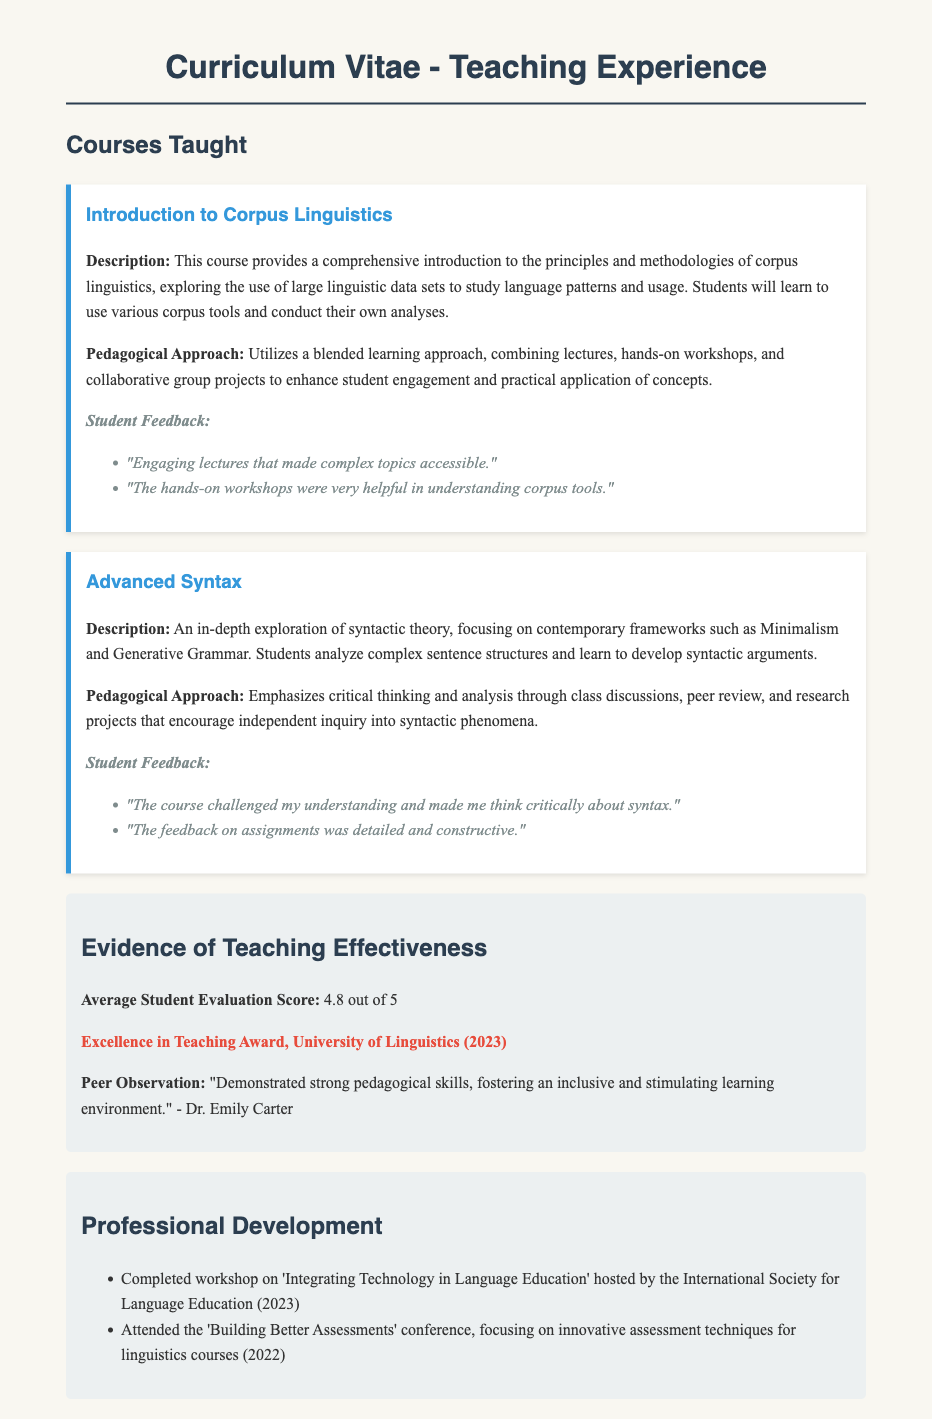What is the title of the first course taught? The title of the first course is found at the beginning of the course section, which is "Introduction to Corpus Linguistics."
Answer: Introduction to Corpus Linguistics What is the average student evaluation score? The average student evaluation score is explicitly stated in the section on evidence of teaching effectiveness, which is 4.8 out of 5.
Answer: 4.8 out of 5 What award did the instructor receive in 2023? The award is mentioned in the effectiveness section, where it states "Excellence in Teaching Award, University of Linguistics (2023)."
Answer: Excellence in Teaching Award What pedagogical approach is used in Advanced Syntax? The pedagogical approach for Advanced Syntax is described, focusing on critical thinking and analysis through class discussions, which outlines how the course is taught.
Answer: Emphasizes critical thinking and analysis Who provided the peer observation comment? The peer observation comment is attributed to Dr. Emily Carter, as noted in the evidence of teaching effectiveness section.
Answer: Dr. Emily Carter What is the main focus of the workshop completed in 2023? The workshop's focus is outlined in the professional development section, which states it was about 'Integrating Technology in Language Education.'
Answer: Integrating Technology in Language Education What kind of feedback did students give for "Introduction to Corpus Linguistics"? The specific feedback is listed under the student feedback for the course, highlighting the quality of lectures and workshops.
Answer: "Engaging lectures that made complex topics accessible." What type of learning approach is utilized in "Introduction to Corpus Linguistics"? The type of learning approach is detailed in the description, indicating a blended learning approach combining multiple educational methods.
Answer: Blended learning approach 